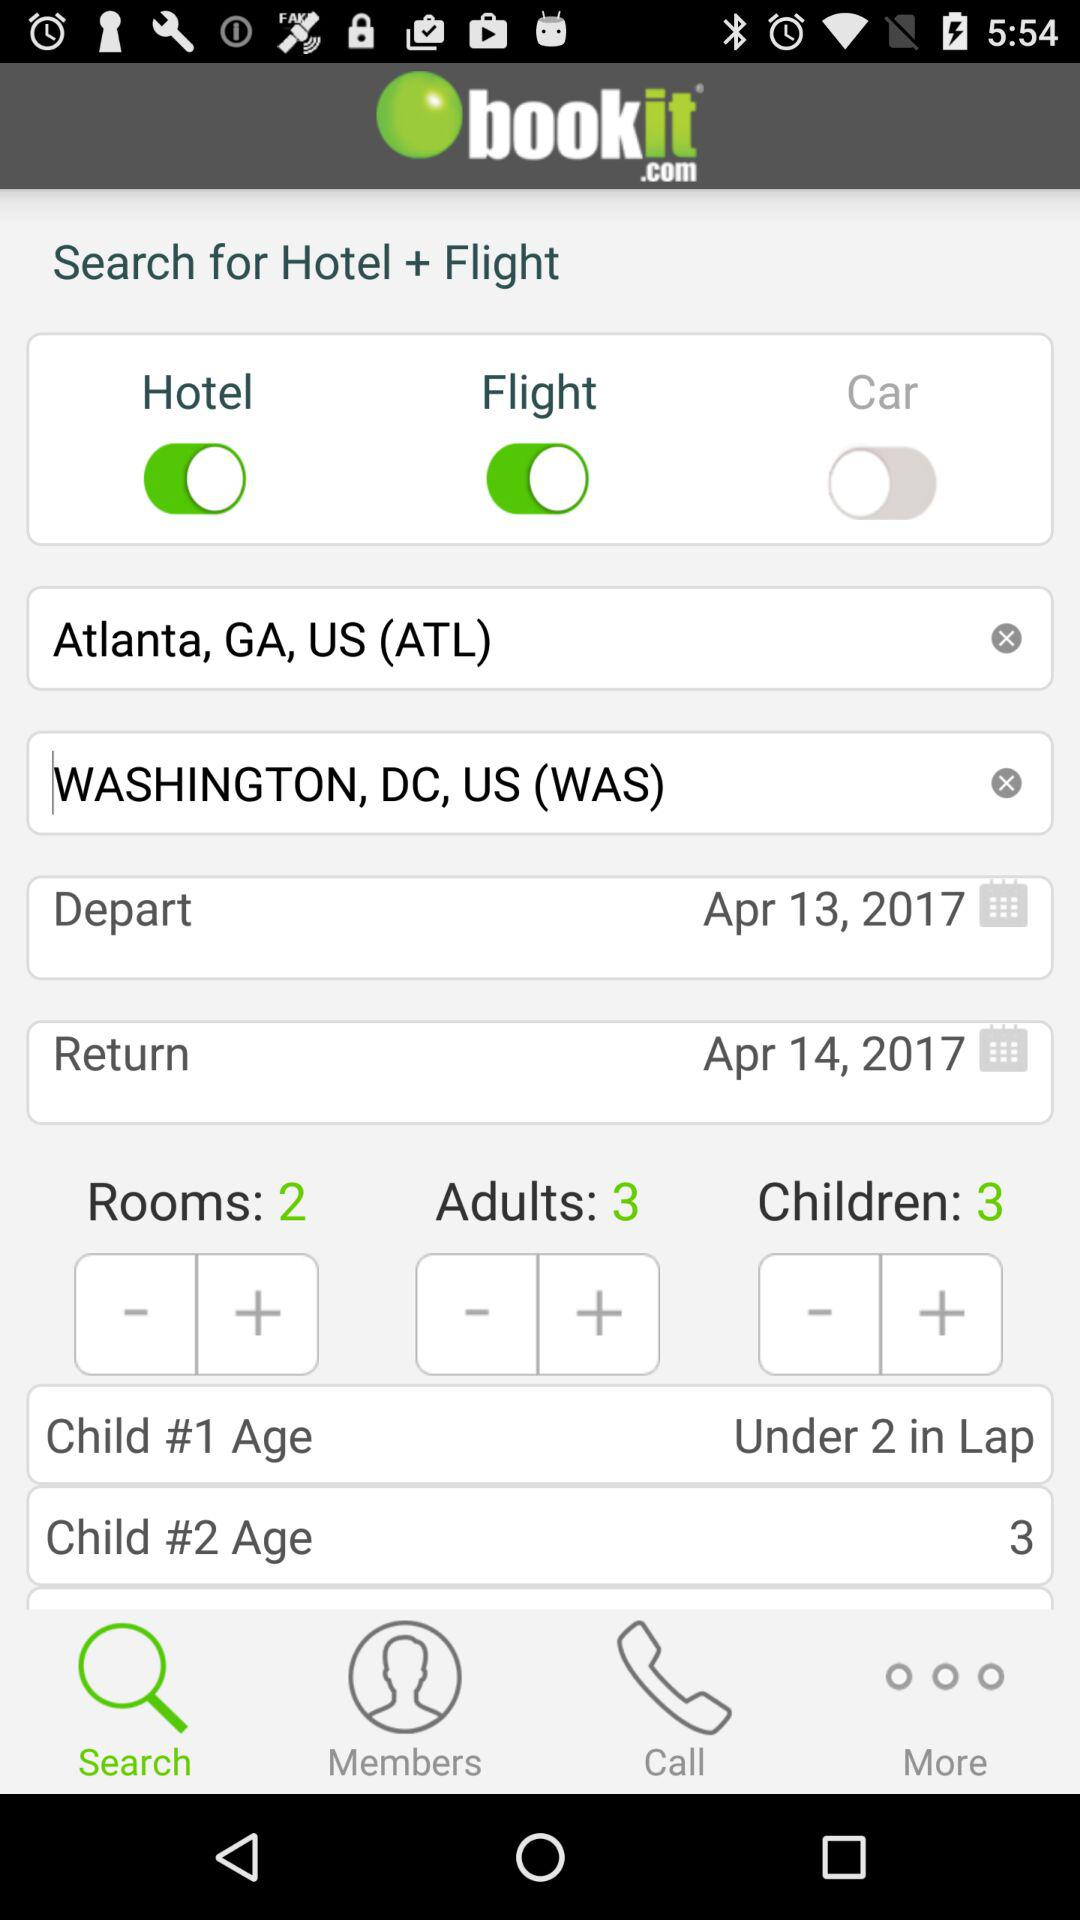What is the current status of the "Flight"? The current status of the "Flight" is "on". 